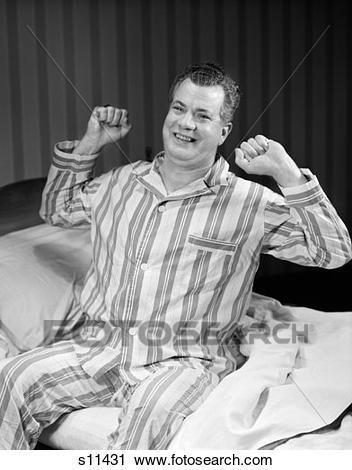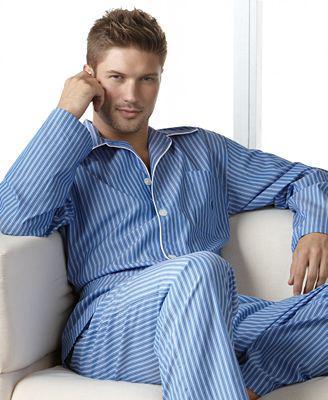The first image is the image on the left, the second image is the image on the right. Examine the images to the left and right. Is the description "the right image shows a man in a seated position wearing blue, long sleeved pajamas" accurate? Answer yes or no. Yes. The first image is the image on the left, the second image is the image on the right. Assess this claim about the two images: "An image includes one forward-facing man in sleepwear who is lifting a corded black telephone to his ear, and the other image shows a man standing wearing grey sweatpants.". Correct or not? Answer yes or no. No. 